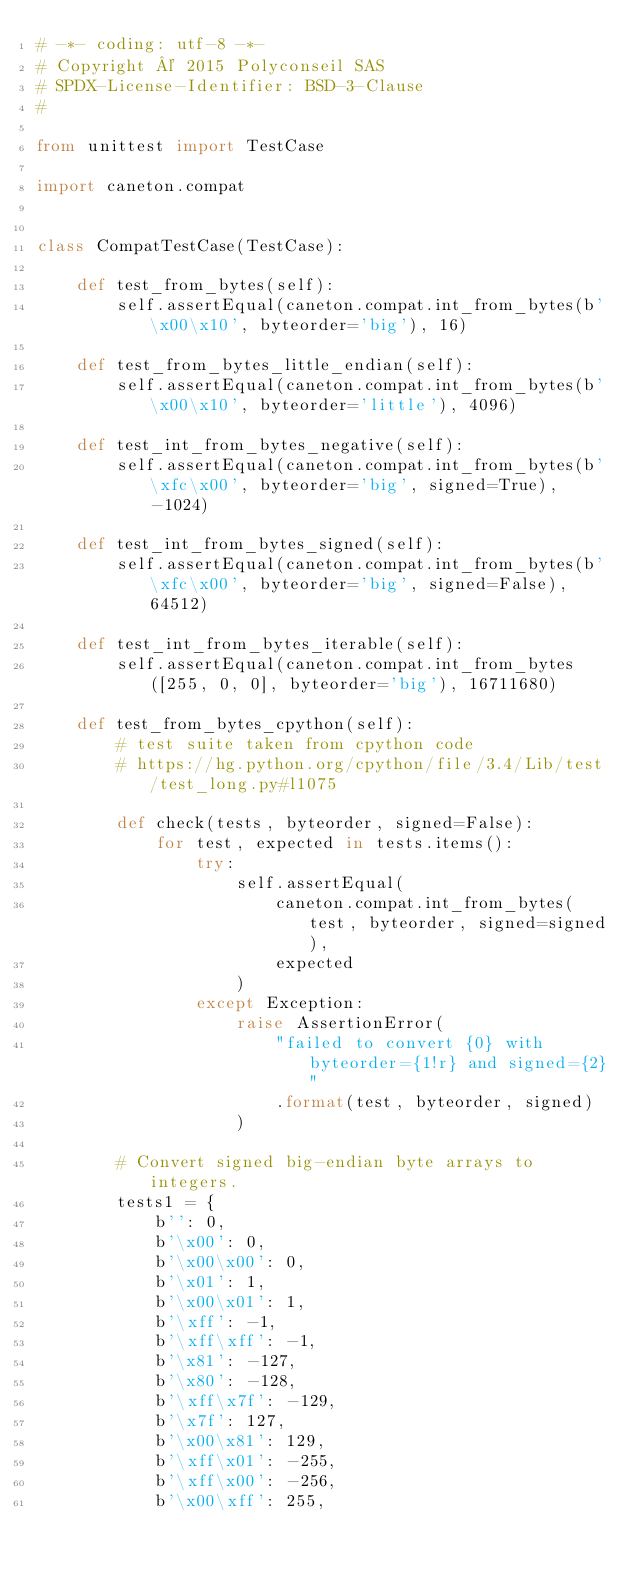Convert code to text. <code><loc_0><loc_0><loc_500><loc_500><_Python_># -*- coding: utf-8 -*-
# Copyright © 2015 Polyconseil SAS
# SPDX-License-Identifier: BSD-3-Clause
#

from unittest import TestCase

import caneton.compat


class CompatTestCase(TestCase):

    def test_from_bytes(self):
        self.assertEqual(caneton.compat.int_from_bytes(b'\x00\x10', byteorder='big'), 16)

    def test_from_bytes_little_endian(self):
        self.assertEqual(caneton.compat.int_from_bytes(b'\x00\x10', byteorder='little'), 4096)

    def test_int_from_bytes_negative(self):
        self.assertEqual(caneton.compat.int_from_bytes(b'\xfc\x00', byteorder='big', signed=True), -1024)

    def test_int_from_bytes_signed(self):
        self.assertEqual(caneton.compat.int_from_bytes(b'\xfc\x00', byteorder='big', signed=False), 64512)

    def test_int_from_bytes_iterable(self):
        self.assertEqual(caneton.compat.int_from_bytes([255, 0, 0], byteorder='big'), 16711680)

    def test_from_bytes_cpython(self):
        # test suite taken from cpython code
        # https://hg.python.org/cpython/file/3.4/Lib/test/test_long.py#l1075

        def check(tests, byteorder, signed=False):
            for test, expected in tests.items():
                try:
                    self.assertEqual(
                        caneton.compat.int_from_bytes(test, byteorder, signed=signed),
                        expected
                    )
                except Exception:
                    raise AssertionError(
                        "failed to convert {0} with byteorder={1!r} and signed={2}"
                        .format(test, byteorder, signed)
                    )

        # Convert signed big-endian byte arrays to integers.
        tests1 = {
            b'': 0,
            b'\x00': 0,
            b'\x00\x00': 0,
            b'\x01': 1,
            b'\x00\x01': 1,
            b'\xff': -1,
            b'\xff\xff': -1,
            b'\x81': -127,
            b'\x80': -128,
            b'\xff\x7f': -129,
            b'\x7f': 127,
            b'\x00\x81': 129,
            b'\xff\x01': -255,
            b'\xff\x00': -256,
            b'\x00\xff': 255,</code> 